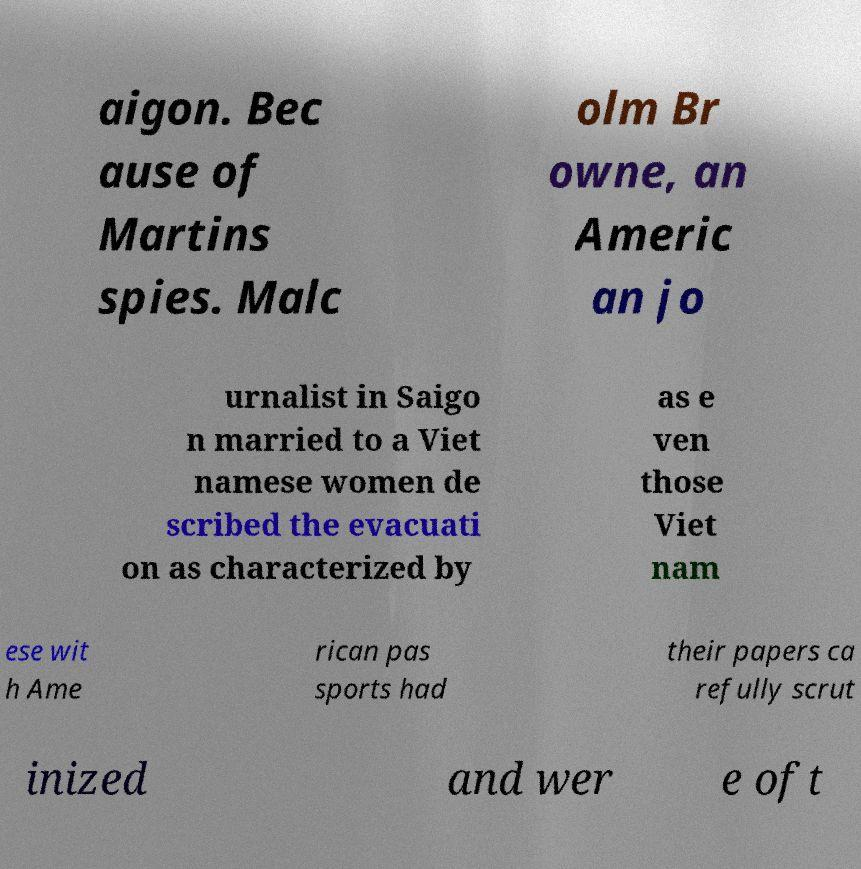What messages or text are displayed in this image? I need them in a readable, typed format. aigon. Bec ause of Martins spies. Malc olm Br owne, an Americ an jo urnalist in Saigo n married to a Viet namese women de scribed the evacuati on as characterized by as e ven those Viet nam ese wit h Ame rican pas sports had their papers ca refully scrut inized and wer e oft 